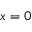<formula> <loc_0><loc_0><loc_500><loc_500>x = 0</formula> 